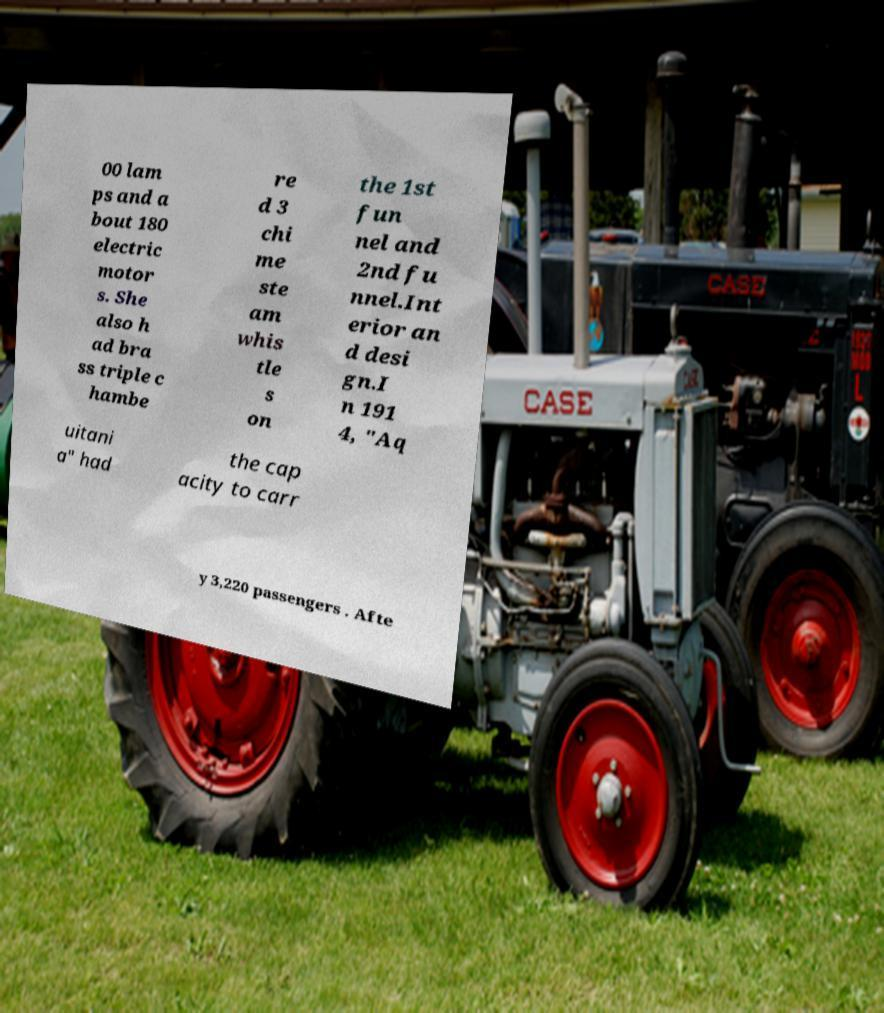For documentation purposes, I need the text within this image transcribed. Could you provide that? 00 lam ps and a bout 180 electric motor s. She also h ad bra ss triple c hambe re d 3 chi me ste am whis tle s on the 1st fun nel and 2nd fu nnel.Int erior an d desi gn.I n 191 4, "Aq uitani a" had the cap acity to carr y 3,220 passengers . Afte 